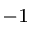Convert formula to latex. <formula><loc_0><loc_0><loc_500><loc_500>^ { - 1 }</formula> 